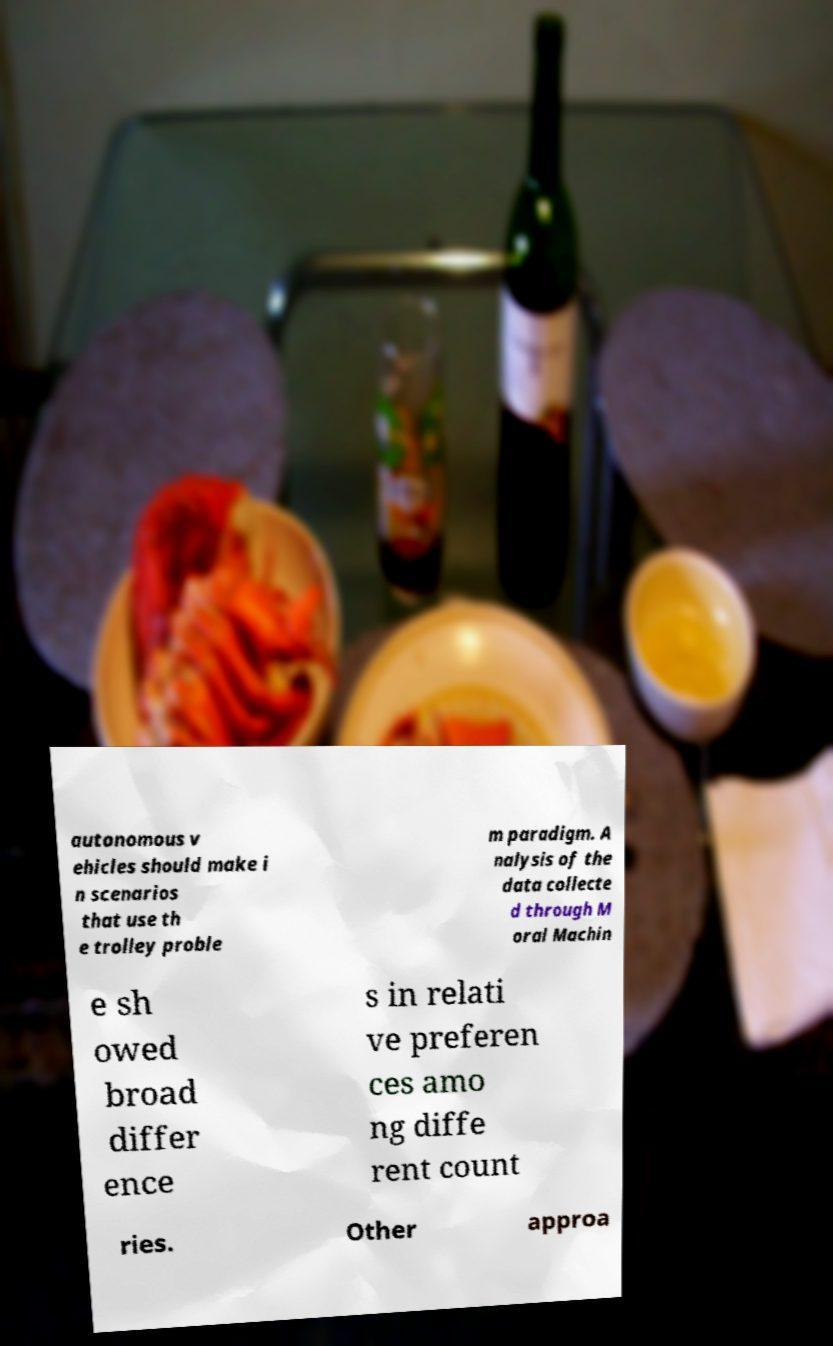Please read and relay the text visible in this image. What does it say? autonomous v ehicles should make i n scenarios that use th e trolley proble m paradigm. A nalysis of the data collecte d through M oral Machin e sh owed broad differ ence s in relati ve preferen ces amo ng diffe rent count ries. Other approa 